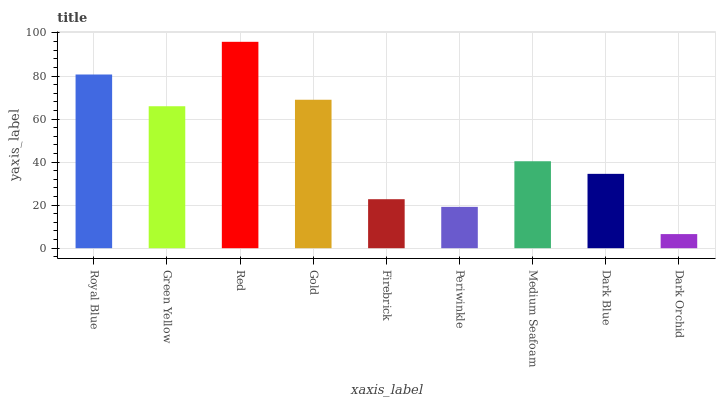Is Green Yellow the minimum?
Answer yes or no. No. Is Green Yellow the maximum?
Answer yes or no. No. Is Royal Blue greater than Green Yellow?
Answer yes or no. Yes. Is Green Yellow less than Royal Blue?
Answer yes or no. Yes. Is Green Yellow greater than Royal Blue?
Answer yes or no. No. Is Royal Blue less than Green Yellow?
Answer yes or no. No. Is Medium Seafoam the high median?
Answer yes or no. Yes. Is Medium Seafoam the low median?
Answer yes or no. Yes. Is Dark Blue the high median?
Answer yes or no. No. Is Periwinkle the low median?
Answer yes or no. No. 